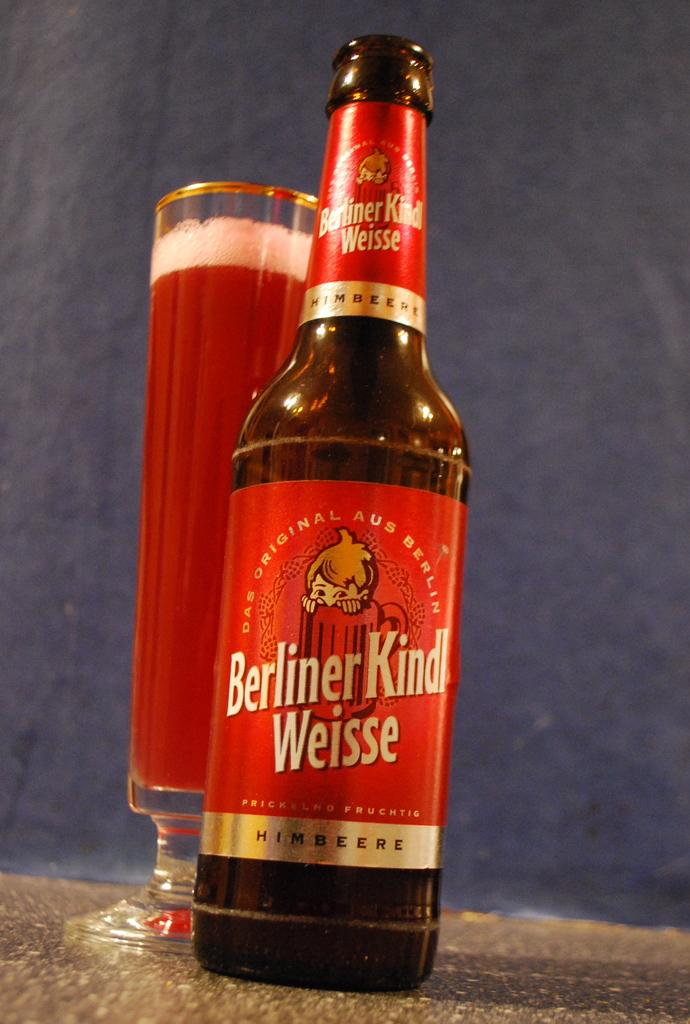<image>
Render a clear and concise summary of the photo. A glass of beer sits behind a Berliner Kindl Weisse beer bottle. 